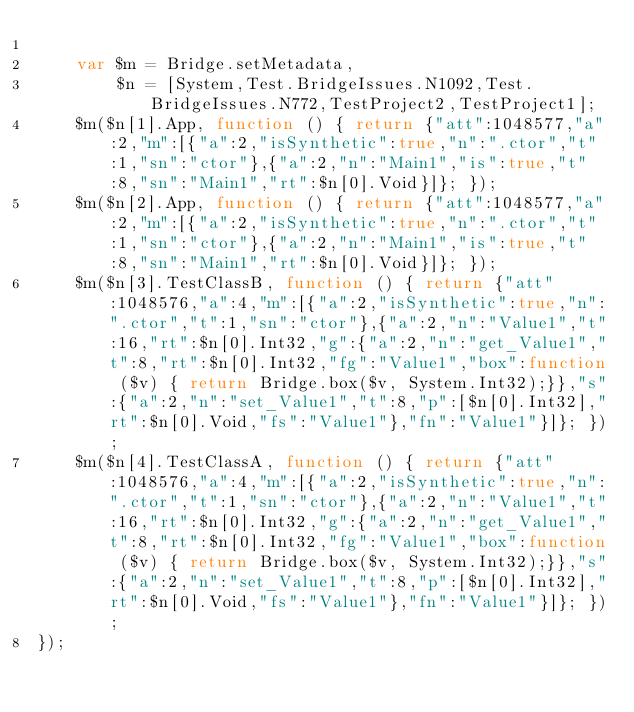Convert code to text. <code><loc_0><loc_0><loc_500><loc_500><_JavaScript_>
    var $m = Bridge.setMetadata,
        $n = [System,Test.BridgeIssues.N1092,Test.BridgeIssues.N772,TestProject2,TestProject1];
    $m($n[1].App, function () { return {"att":1048577,"a":2,"m":[{"a":2,"isSynthetic":true,"n":".ctor","t":1,"sn":"ctor"},{"a":2,"n":"Main1","is":true,"t":8,"sn":"Main1","rt":$n[0].Void}]}; });
    $m($n[2].App, function () { return {"att":1048577,"a":2,"m":[{"a":2,"isSynthetic":true,"n":".ctor","t":1,"sn":"ctor"},{"a":2,"n":"Main1","is":true,"t":8,"sn":"Main1","rt":$n[0].Void}]}; });
    $m($n[3].TestClassB, function () { return {"att":1048576,"a":4,"m":[{"a":2,"isSynthetic":true,"n":".ctor","t":1,"sn":"ctor"},{"a":2,"n":"Value1","t":16,"rt":$n[0].Int32,"g":{"a":2,"n":"get_Value1","t":8,"rt":$n[0].Int32,"fg":"Value1","box":function ($v) { return Bridge.box($v, System.Int32);}},"s":{"a":2,"n":"set_Value1","t":8,"p":[$n[0].Int32],"rt":$n[0].Void,"fs":"Value1"},"fn":"Value1"}]}; });
    $m($n[4].TestClassA, function () { return {"att":1048576,"a":4,"m":[{"a":2,"isSynthetic":true,"n":".ctor","t":1,"sn":"ctor"},{"a":2,"n":"Value1","t":16,"rt":$n[0].Int32,"g":{"a":2,"n":"get_Value1","t":8,"rt":$n[0].Int32,"fg":"Value1","box":function ($v) { return Bridge.box($v, System.Int32);}},"s":{"a":2,"n":"set_Value1","t":8,"p":[$n[0].Int32],"rt":$n[0].Void,"fs":"Value1"},"fn":"Value1"}]}; });
});
</code> 